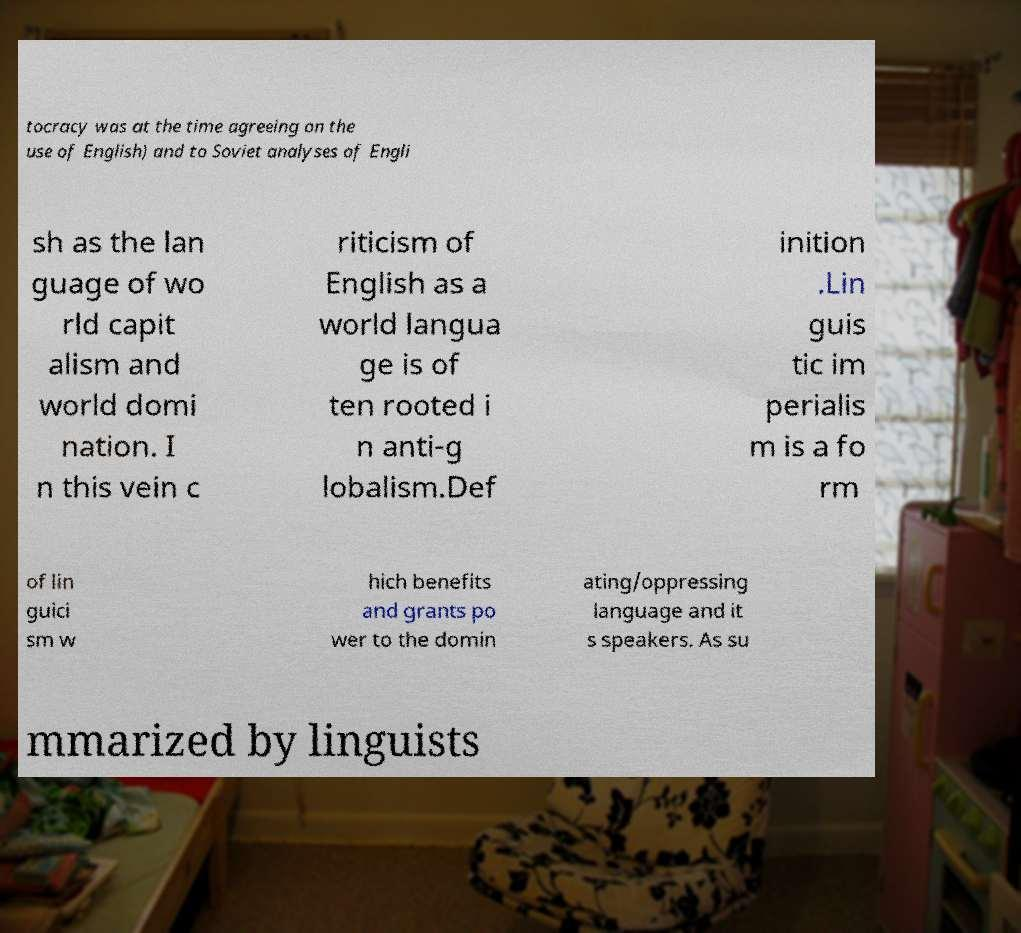What messages or text are displayed in this image? I need them in a readable, typed format. tocracy was at the time agreeing on the use of English) and to Soviet analyses of Engli sh as the lan guage of wo rld capit alism and world domi nation. I n this vein c riticism of English as a world langua ge is of ten rooted i n anti-g lobalism.Def inition .Lin guis tic im perialis m is a fo rm of lin guici sm w hich benefits and grants po wer to the domin ating/oppressing language and it s speakers. As su mmarized by linguists 